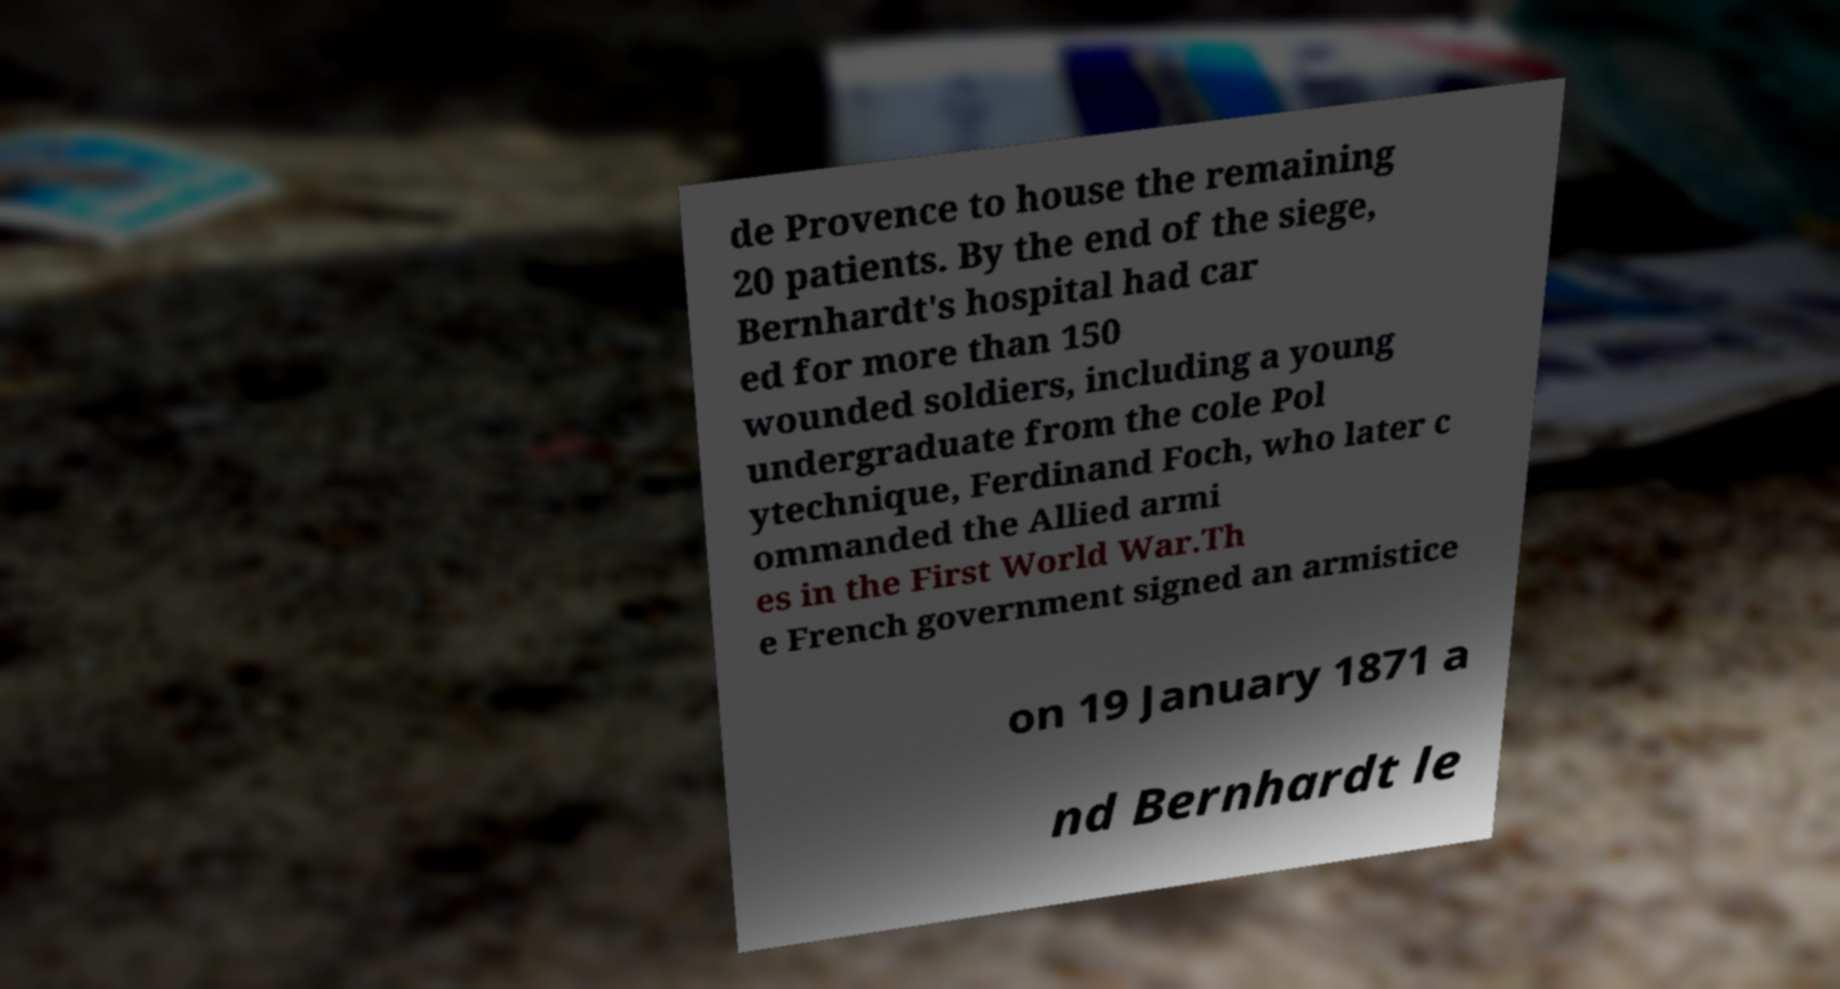What messages or text are displayed in this image? I need them in a readable, typed format. de Provence to house the remaining 20 patients. By the end of the siege, Bernhardt's hospital had car ed for more than 150 wounded soldiers, including a young undergraduate from the cole Pol ytechnique, Ferdinand Foch, who later c ommanded the Allied armi es in the First World War.Th e French government signed an armistice on 19 January 1871 a nd Bernhardt le 